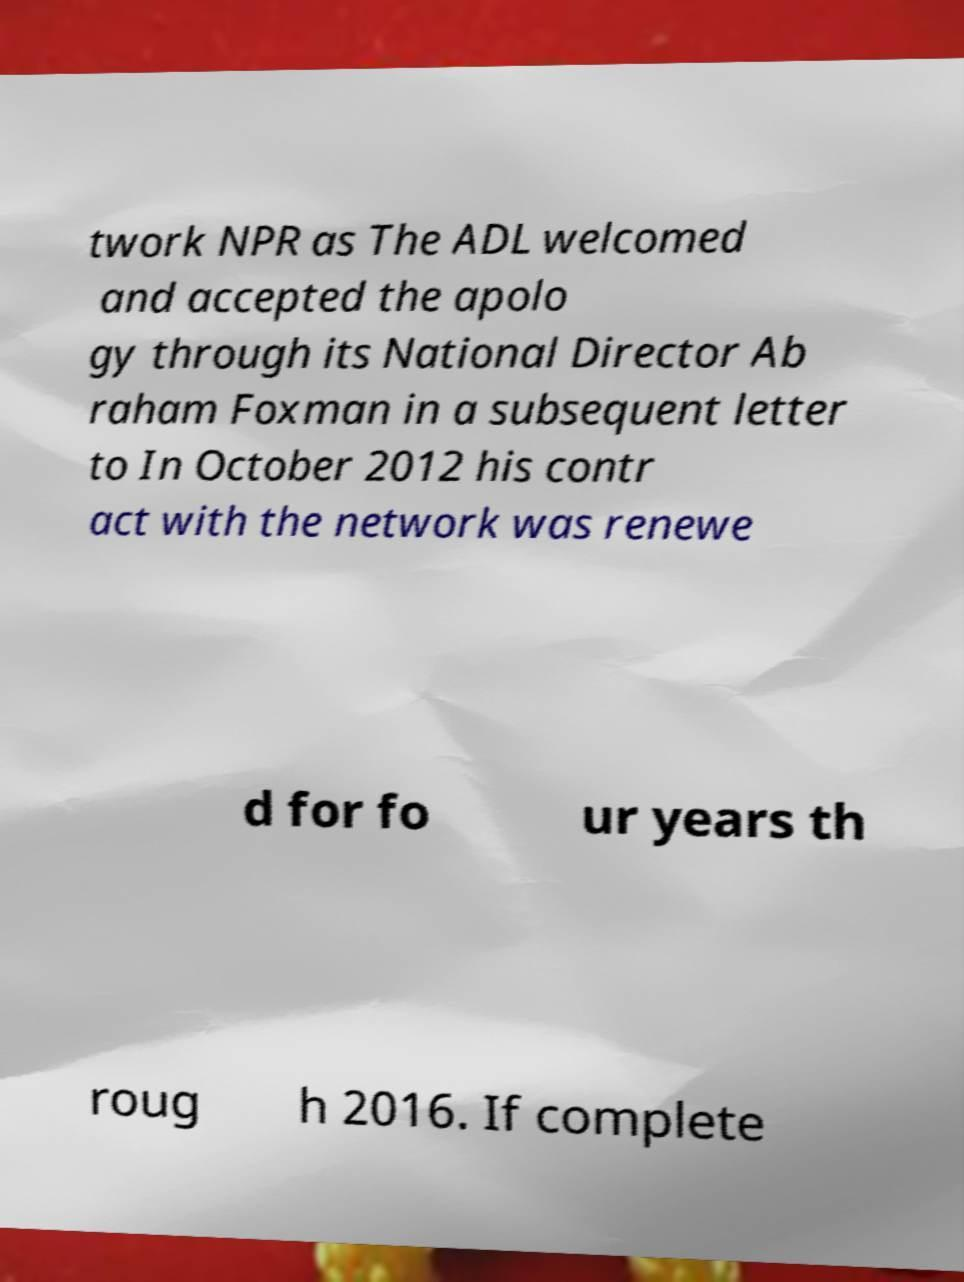Can you accurately transcribe the text from the provided image for me? twork NPR as The ADL welcomed and accepted the apolo gy through its National Director Ab raham Foxman in a subsequent letter to In October 2012 his contr act with the network was renewe d for fo ur years th roug h 2016. If complete 